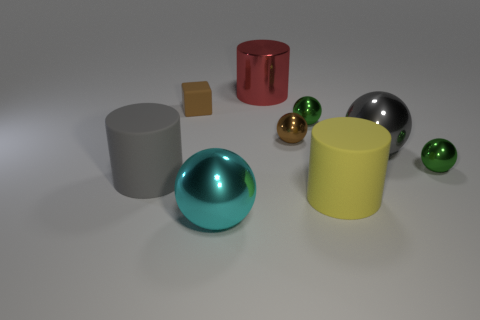There is a large gray object that is behind the gray rubber cylinder; is its shape the same as the cyan thing?
Provide a succinct answer. Yes. What color is the matte block?
Your response must be concise. Brown. There is a thing that is the same color as the matte cube; what shape is it?
Your answer should be very brief. Sphere. Are any cylinders visible?
Provide a succinct answer. Yes. What size is the gray object that is made of the same material as the small brown cube?
Provide a short and direct response. Large. There is a green object behind the tiny green metal sphere that is in front of the tiny brown object on the right side of the cyan ball; what is its shape?
Provide a short and direct response. Sphere. Are there the same number of small brown blocks that are behind the brown metal object and yellow matte cylinders?
Your response must be concise. Yes. What size is the other object that is the same color as the tiny rubber thing?
Keep it short and to the point. Small. Does the large cyan object have the same shape as the gray shiny object?
Your answer should be compact. Yes. How many objects are either matte cylinders to the right of the tiny brown cube or brown cubes?
Keep it short and to the point. 2. 